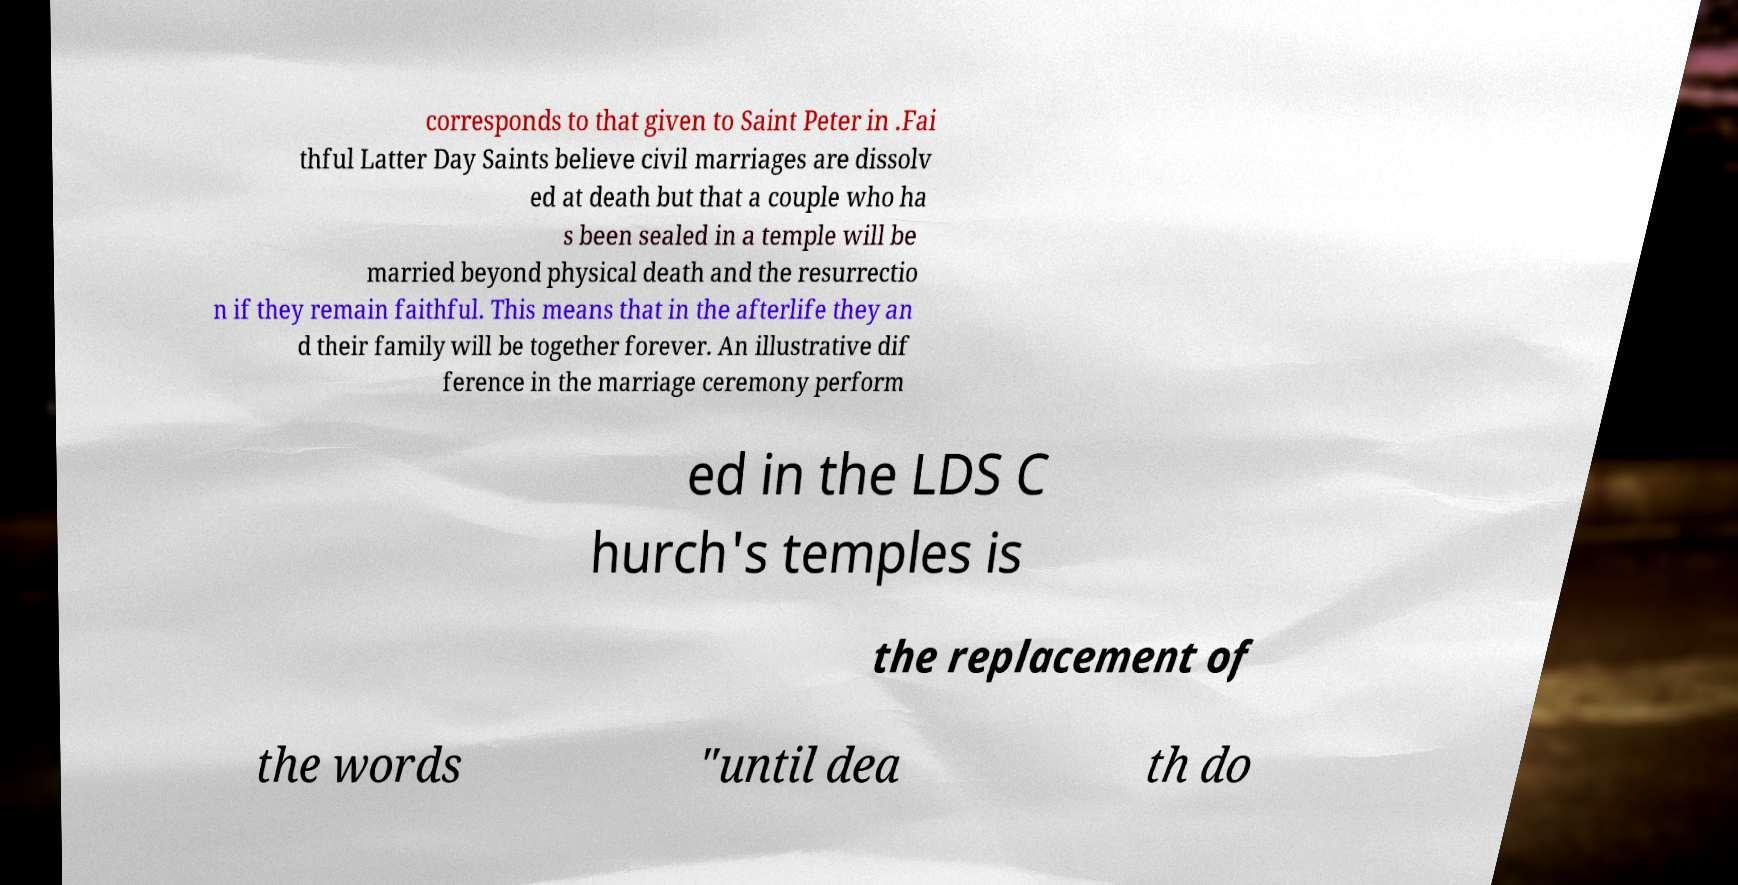For documentation purposes, I need the text within this image transcribed. Could you provide that? corresponds to that given to Saint Peter in .Fai thful Latter Day Saints believe civil marriages are dissolv ed at death but that a couple who ha s been sealed in a temple will be married beyond physical death and the resurrectio n if they remain faithful. This means that in the afterlife they an d their family will be together forever. An illustrative dif ference in the marriage ceremony perform ed in the LDS C hurch's temples is the replacement of the words "until dea th do 